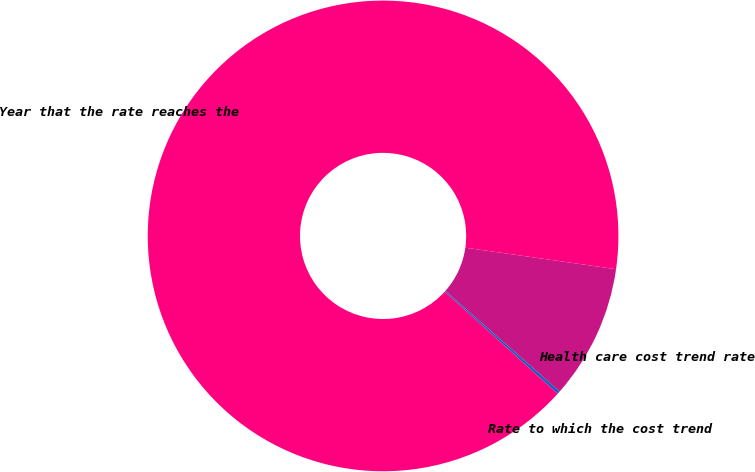Convert chart. <chart><loc_0><loc_0><loc_500><loc_500><pie_chart><fcel>Health care cost trend rate<fcel>Rate to which the cost trend<fcel>Year that the rate reaches the<nl><fcel>9.24%<fcel>0.2%<fcel>90.56%<nl></chart> 